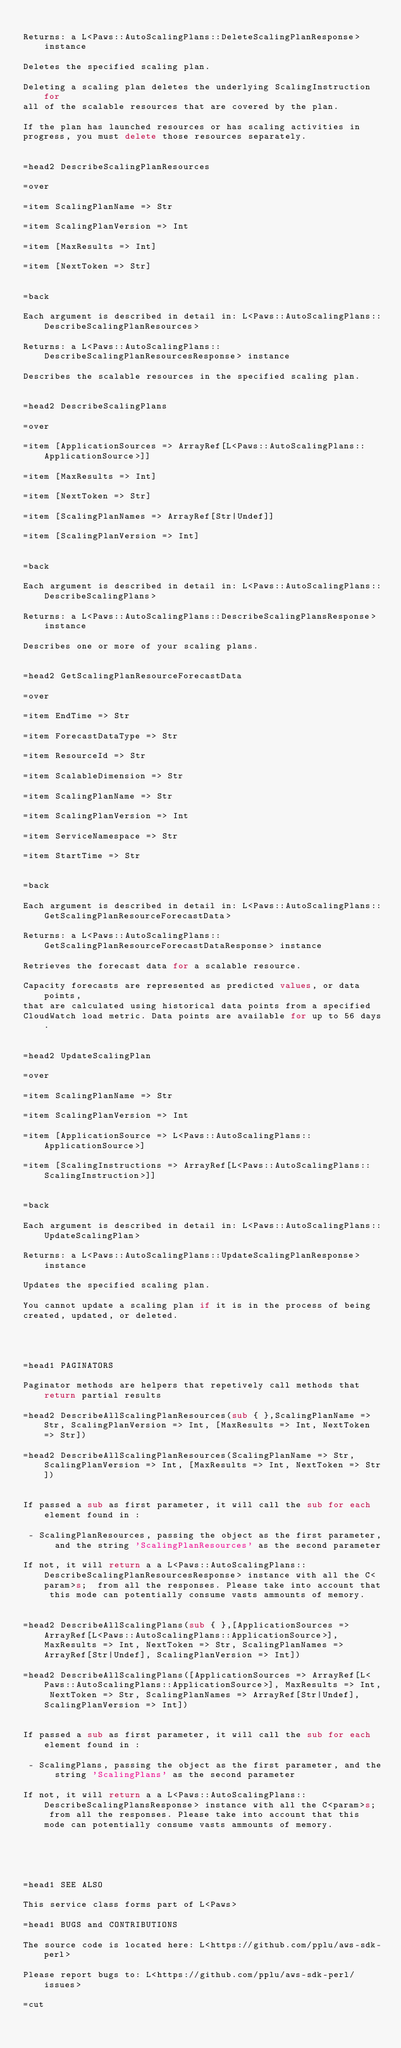<code> <loc_0><loc_0><loc_500><loc_500><_Perl_>
Returns: a L<Paws::AutoScalingPlans::DeleteScalingPlanResponse> instance

Deletes the specified scaling plan.

Deleting a scaling plan deletes the underlying ScalingInstruction for
all of the scalable resources that are covered by the plan.

If the plan has launched resources or has scaling activities in
progress, you must delete those resources separately.


=head2 DescribeScalingPlanResources

=over

=item ScalingPlanName => Str

=item ScalingPlanVersion => Int

=item [MaxResults => Int]

=item [NextToken => Str]


=back

Each argument is described in detail in: L<Paws::AutoScalingPlans::DescribeScalingPlanResources>

Returns: a L<Paws::AutoScalingPlans::DescribeScalingPlanResourcesResponse> instance

Describes the scalable resources in the specified scaling plan.


=head2 DescribeScalingPlans

=over

=item [ApplicationSources => ArrayRef[L<Paws::AutoScalingPlans::ApplicationSource>]]

=item [MaxResults => Int]

=item [NextToken => Str]

=item [ScalingPlanNames => ArrayRef[Str|Undef]]

=item [ScalingPlanVersion => Int]


=back

Each argument is described in detail in: L<Paws::AutoScalingPlans::DescribeScalingPlans>

Returns: a L<Paws::AutoScalingPlans::DescribeScalingPlansResponse> instance

Describes one or more of your scaling plans.


=head2 GetScalingPlanResourceForecastData

=over

=item EndTime => Str

=item ForecastDataType => Str

=item ResourceId => Str

=item ScalableDimension => Str

=item ScalingPlanName => Str

=item ScalingPlanVersion => Int

=item ServiceNamespace => Str

=item StartTime => Str


=back

Each argument is described in detail in: L<Paws::AutoScalingPlans::GetScalingPlanResourceForecastData>

Returns: a L<Paws::AutoScalingPlans::GetScalingPlanResourceForecastDataResponse> instance

Retrieves the forecast data for a scalable resource.

Capacity forecasts are represented as predicted values, or data points,
that are calculated using historical data points from a specified
CloudWatch load metric. Data points are available for up to 56 days.


=head2 UpdateScalingPlan

=over

=item ScalingPlanName => Str

=item ScalingPlanVersion => Int

=item [ApplicationSource => L<Paws::AutoScalingPlans::ApplicationSource>]

=item [ScalingInstructions => ArrayRef[L<Paws::AutoScalingPlans::ScalingInstruction>]]


=back

Each argument is described in detail in: L<Paws::AutoScalingPlans::UpdateScalingPlan>

Returns: a L<Paws::AutoScalingPlans::UpdateScalingPlanResponse> instance

Updates the specified scaling plan.

You cannot update a scaling plan if it is in the process of being
created, updated, or deleted.




=head1 PAGINATORS

Paginator methods are helpers that repetively call methods that return partial results

=head2 DescribeAllScalingPlanResources(sub { },ScalingPlanName => Str, ScalingPlanVersion => Int, [MaxResults => Int, NextToken => Str])

=head2 DescribeAllScalingPlanResources(ScalingPlanName => Str, ScalingPlanVersion => Int, [MaxResults => Int, NextToken => Str])


If passed a sub as first parameter, it will call the sub for each element found in :

 - ScalingPlanResources, passing the object as the first parameter, and the string 'ScalingPlanResources' as the second parameter 

If not, it will return a a L<Paws::AutoScalingPlans::DescribeScalingPlanResourcesResponse> instance with all the C<param>s;  from all the responses. Please take into account that this mode can potentially consume vasts ammounts of memory.


=head2 DescribeAllScalingPlans(sub { },[ApplicationSources => ArrayRef[L<Paws::AutoScalingPlans::ApplicationSource>], MaxResults => Int, NextToken => Str, ScalingPlanNames => ArrayRef[Str|Undef], ScalingPlanVersion => Int])

=head2 DescribeAllScalingPlans([ApplicationSources => ArrayRef[L<Paws::AutoScalingPlans::ApplicationSource>], MaxResults => Int, NextToken => Str, ScalingPlanNames => ArrayRef[Str|Undef], ScalingPlanVersion => Int])


If passed a sub as first parameter, it will call the sub for each element found in :

 - ScalingPlans, passing the object as the first parameter, and the string 'ScalingPlans' as the second parameter 

If not, it will return a a L<Paws::AutoScalingPlans::DescribeScalingPlansResponse> instance with all the C<param>s;  from all the responses. Please take into account that this mode can potentially consume vasts ammounts of memory.





=head1 SEE ALSO

This service class forms part of L<Paws>

=head1 BUGS and CONTRIBUTIONS

The source code is located here: L<https://github.com/pplu/aws-sdk-perl>

Please report bugs to: L<https://github.com/pplu/aws-sdk-perl/issues>

=cut

</code> 